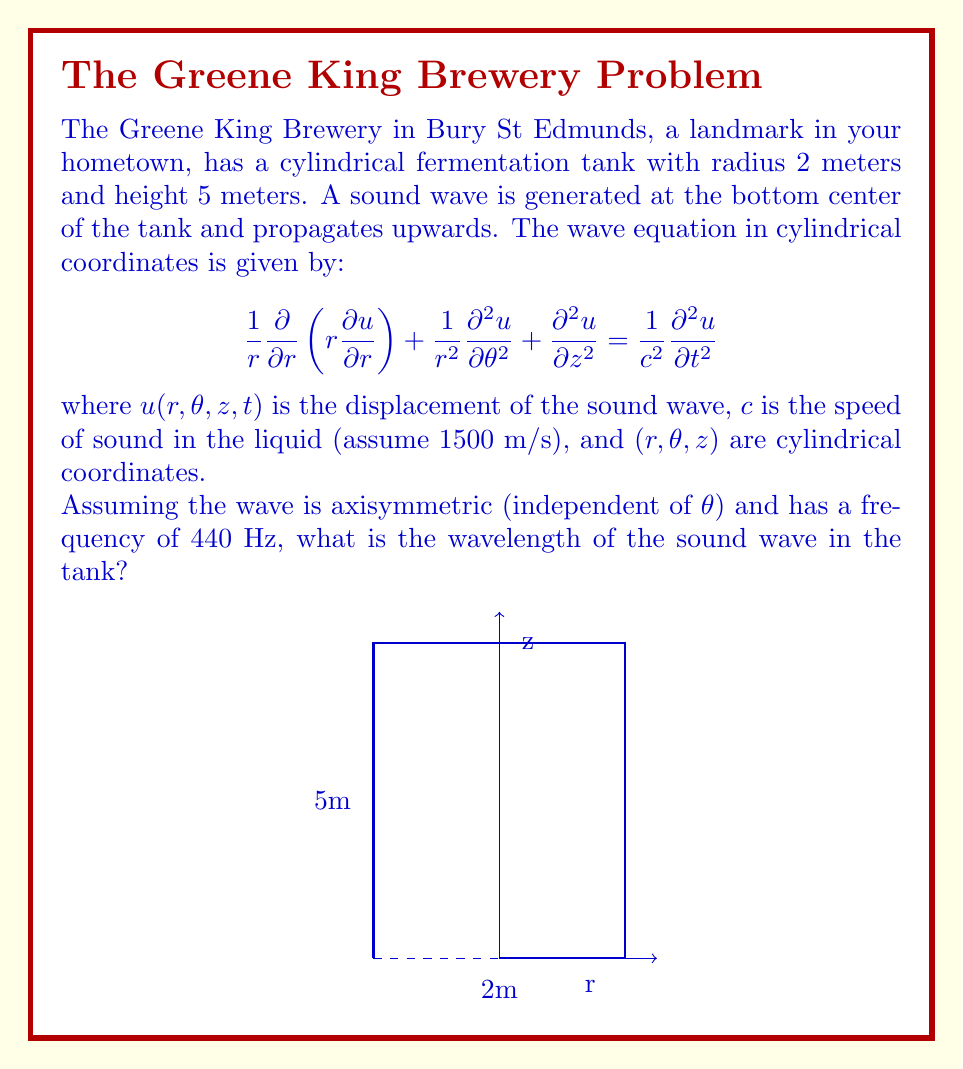Solve this math problem. Let's approach this step-by-step:

1) The wavelength $\lambda$ is related to the frequency $f$ and the speed of sound $c$ by the equation:

   $$c = f\lambda$$

2) We are given that the frequency is 440 Hz and the speed of sound in the liquid is 1500 m/s.

3) Substituting these values into the equation:

   $$1500 = 440\lambda$$

4) Solving for $\lambda$:

   $$\lambda = \frac{1500}{440}$$

5) Calculating:

   $$\lambda = 3.409090909... \text{ meters}$$

6) Rounding to three decimal places:

   $$\lambda \approx 3.409 \text{ meters}$$

This wavelength is longer than the radius of the tank (2 meters) but shorter than its height (5 meters), which means the sound wave will fit vertically in the tank but will reflect off the sides.
Answer: $\lambda \approx 3.409 \text{ meters}$ 